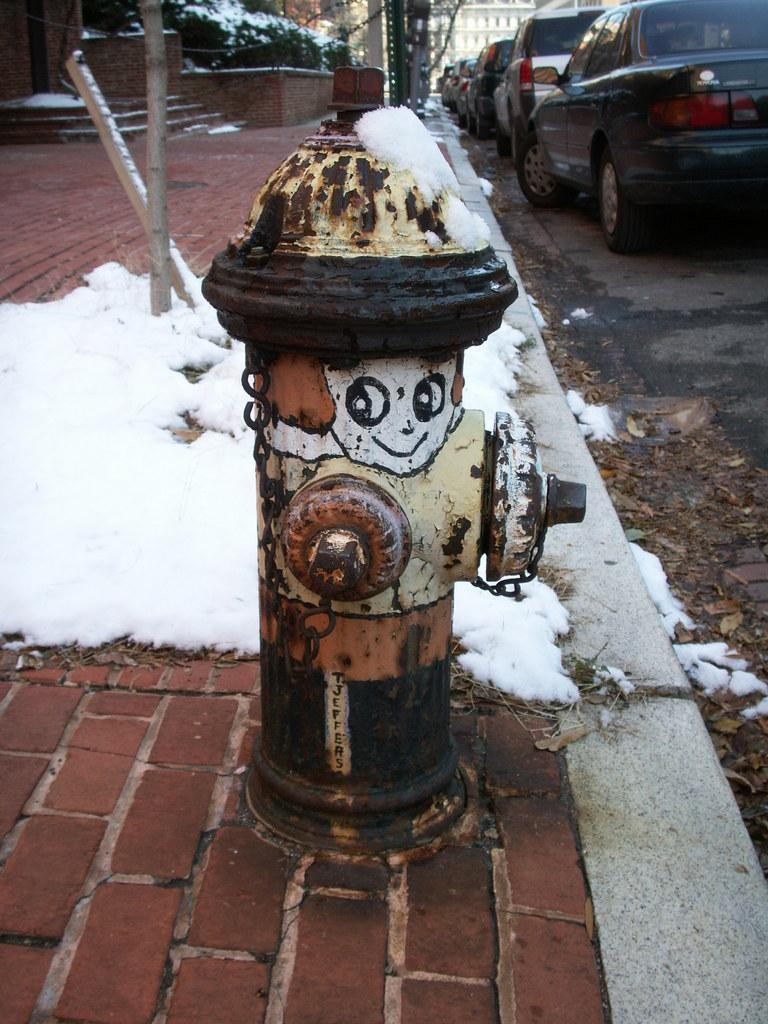What type of surface is visible in the image? There is a sidewalk in the image. What can be seen on the sidewalk? There is a white object on the sidewalk. What structures are present in the image? There are poles and a standpipe in the image. What type of area is depicted in the image? There is a road in the image, and vehicles are present on it. What type of ticket is being sold on the sidewalk in the image? There is no ticket being sold on the sidewalk in the image. What advertisement can be seen on the poles in the image? There are no advertisements visible on the poles in the image. 